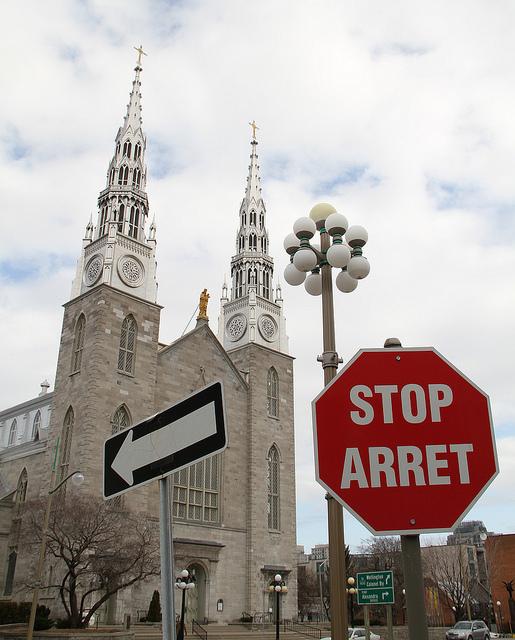Do the signals indicate that it is OK to proceed?
Answer briefly. No. Is the sign in multiple languages?
Give a very brief answer. Yes. What does the red/white/black traffic sign mean?
Answer briefly. Stop. What ways do the arrows point?
Concise answer only. Left. How many words are on the sign?
Give a very brief answer. 2. What does the sign say?
Quick response, please. Stop arret. What color is the sign?
Short answer required. Red. Does the arrow point left or right?
Keep it brief. Left. What kind of lamp post is that?
Write a very short answer. Street. 